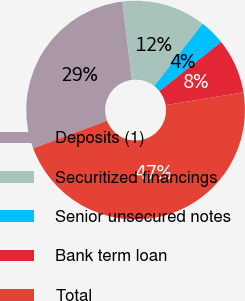Convert chart to OTSL. <chart><loc_0><loc_0><loc_500><loc_500><pie_chart><fcel>Deposits (1)<fcel>Securitized financings<fcel>Senior unsecured notes<fcel>Bank term loan<fcel>Total<nl><fcel>28.76%<fcel>12.42%<fcel>3.8%<fcel>8.11%<fcel>46.91%<nl></chart> 